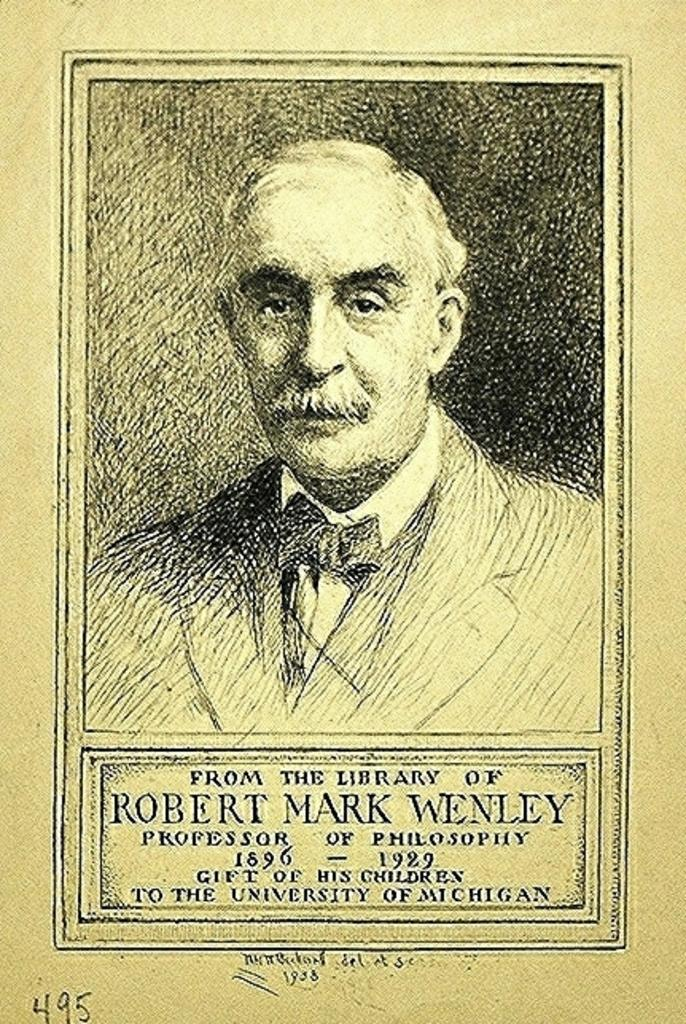What is depicted on the poster in the image? There is a sketch of a man on the poster. Where is the sketch of the man located on the poster? The sketch of the man is at the top of the poster. What else can be found on the poster besides the sketch? There is text at the bottom of the poster. What type of drug is being advertised in the poster? There is no drug being advertised in the poster; it features a sketch of a man and text at the bottom. What need is being addressed by the product or service advertised in the poster? There is no product or service being advertised in the poster, so it is not possible to determine what need is being addressed. 